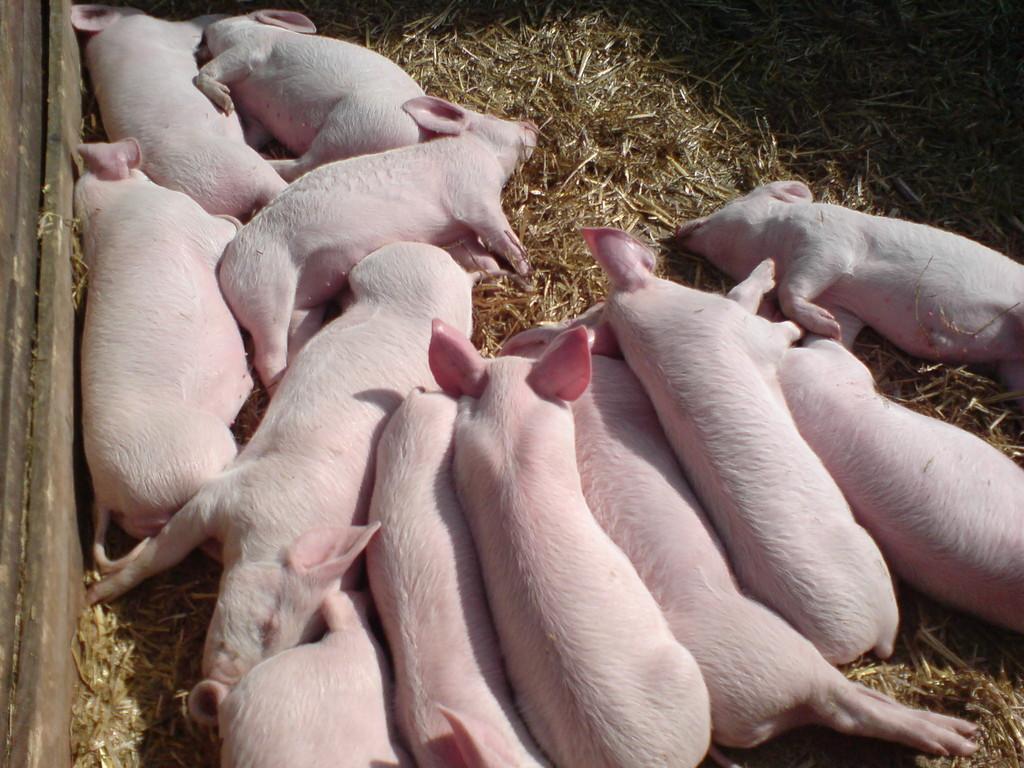Please provide a concise description of this image. In this image, we can see animals which are on the grass. On the left side, we can see a wood wall. 